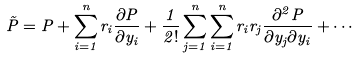Convert formula to latex. <formula><loc_0><loc_0><loc_500><loc_500>\tilde { P } = P + \sum ^ { n } _ { i = 1 } r _ { i } \frac { \partial P } { \partial y _ { i } } + \frac { 1 } { 2 ! } \sum ^ { n } _ { j = 1 } \sum ^ { n } _ { i = 1 } r _ { i } r _ { j } \frac { \partial ^ { 2 } P } { \partial y _ { j } \partial y _ { i } } + \cdots</formula> 